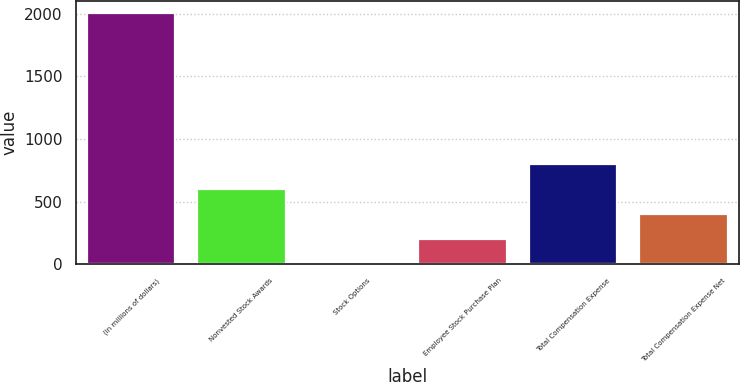Convert chart. <chart><loc_0><loc_0><loc_500><loc_500><bar_chart><fcel>(in millions of dollars)<fcel>Nonvested Stock Awards<fcel>Stock Options<fcel>Employee Stock Purchase Plan<fcel>Total Compensation Expense<fcel>Total Compensation Expense Net<nl><fcel>2007<fcel>602.45<fcel>0.5<fcel>201.15<fcel>803.1<fcel>401.8<nl></chart> 